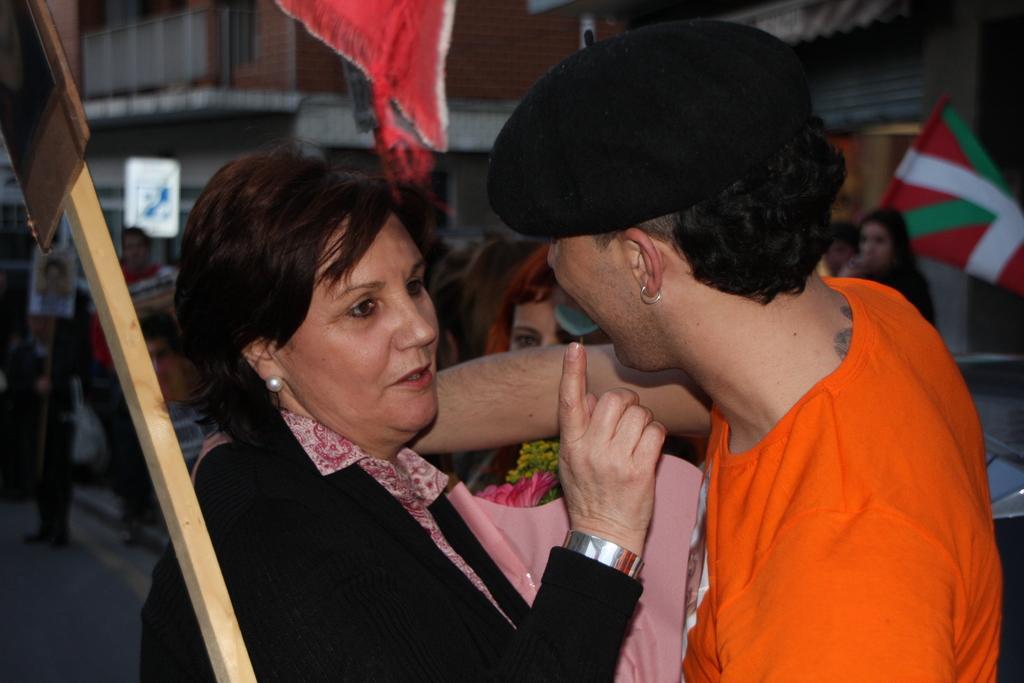In one or two sentences, can you explain what this image depicts? In the picture we can see a woman and a man in front of her looking close and in the background we can see some people are standing and behind them we can see a buildings. 